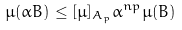<formula> <loc_0><loc_0><loc_500><loc_500>\mu ( \alpha B ) \leq [ \mu ] _ { A _ { p } } \alpha ^ { n p } \mu ( B )</formula> 